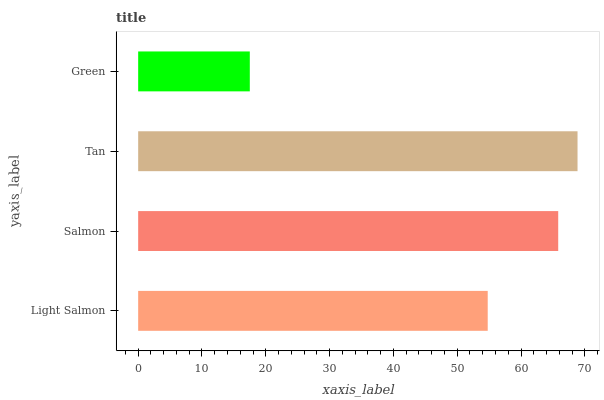Is Green the minimum?
Answer yes or no. Yes. Is Tan the maximum?
Answer yes or no. Yes. Is Salmon the minimum?
Answer yes or no. No. Is Salmon the maximum?
Answer yes or no. No. Is Salmon greater than Light Salmon?
Answer yes or no. Yes. Is Light Salmon less than Salmon?
Answer yes or no. Yes. Is Light Salmon greater than Salmon?
Answer yes or no. No. Is Salmon less than Light Salmon?
Answer yes or no. No. Is Salmon the high median?
Answer yes or no. Yes. Is Light Salmon the low median?
Answer yes or no. Yes. Is Green the high median?
Answer yes or no. No. Is Green the low median?
Answer yes or no. No. 